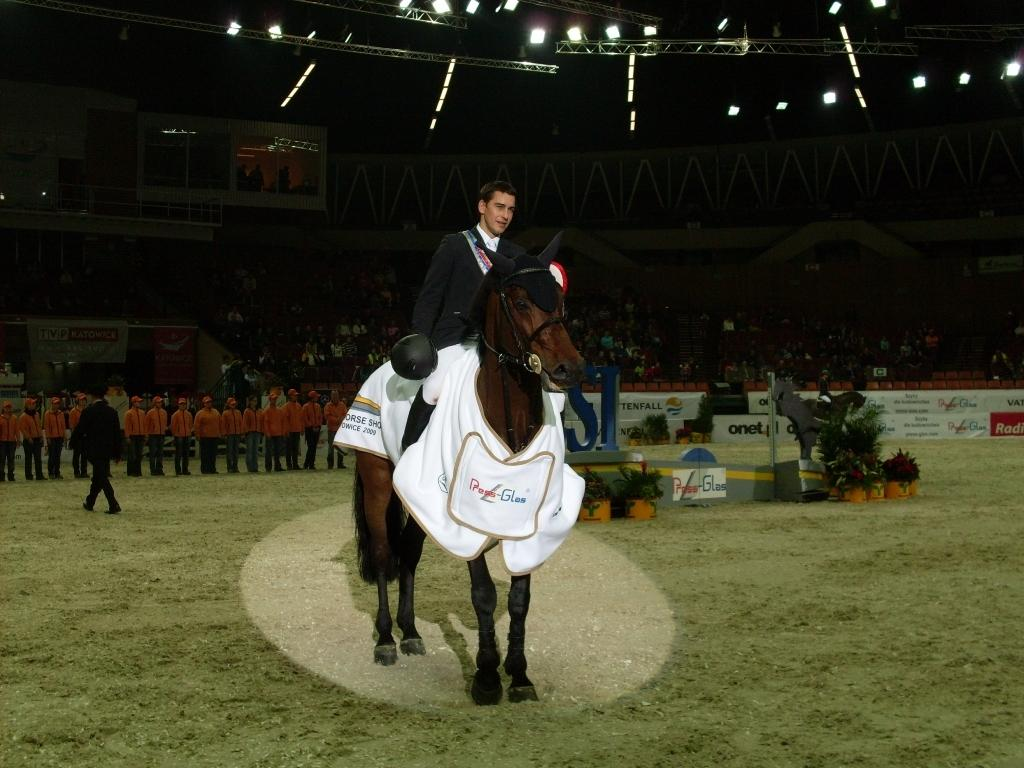What is the man in the image doing? The man is sitting on a horse in the image. What type of surface is the horse standing on? There is grass on the ground in the image. What are the people in the image doing? There are people standing in the image. What can be seen at the top of the image? There are lights visible at the top of the image. What type of plant is being used for transport in the image? There is no plant being used for transport in the image; the man is sitting on a horse. What is the friction between the horse's hooves and the grass in the image? The facts provided do not give information about the friction between the horse's hooves and the grass, so we cannot determine the friction. 